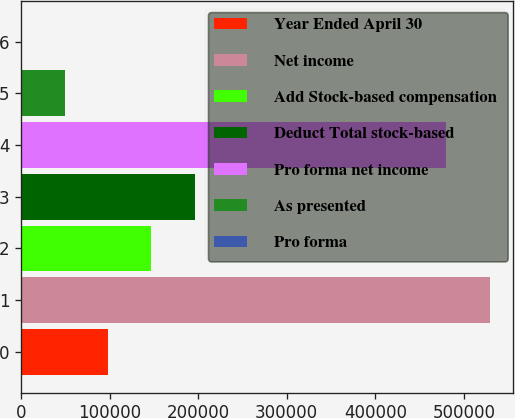<chart> <loc_0><loc_0><loc_500><loc_500><bar_chart><fcel>Year Ended April 30<fcel>Net income<fcel>Add Stock-based compensation<fcel>Deduct Total stock-based<fcel>Pro forma net income<fcel>As presented<fcel>Pro forma<nl><fcel>98082.8<fcel>529275<fcel>147123<fcel>196164<fcel>480234<fcel>49042.1<fcel>1.46<nl></chart> 